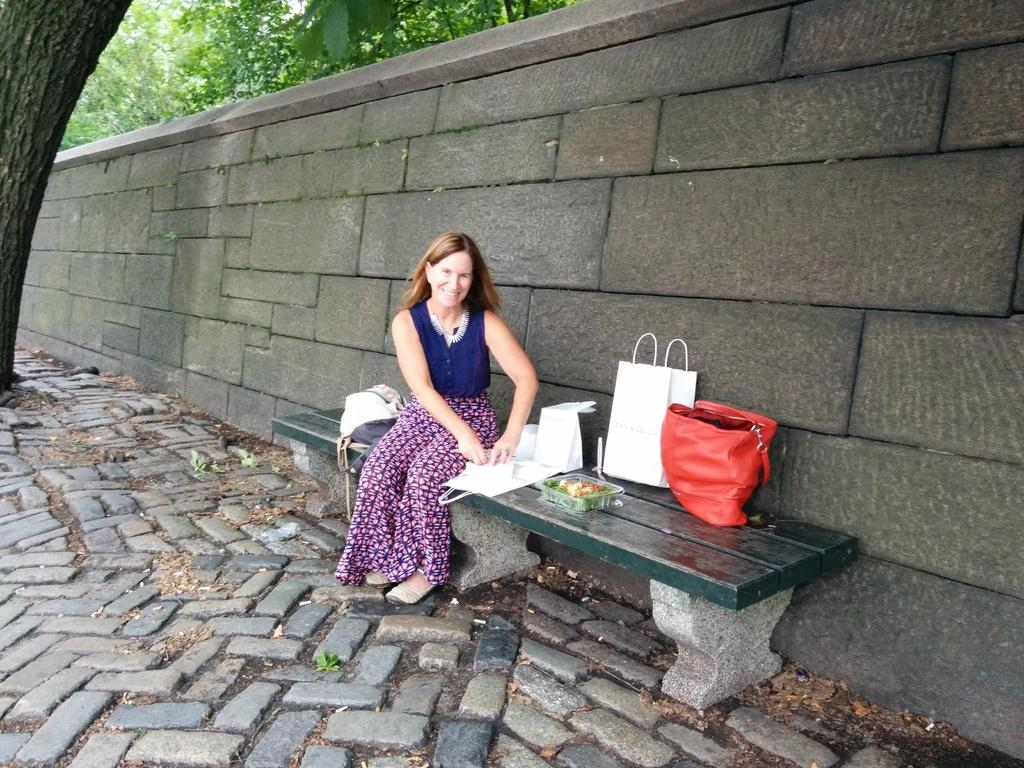Who is present in the image? There is a woman in the image. What is the woman doing in the image? The woman is sitting on a bench. What items can be seen on the bench with the woman? There is a red-colored purse, a white-colored bag, and a box of fruits on the bench. Can you tell me how the goat is helping the woman in the image? There is no goat present in the image, so it cannot help the woman. 